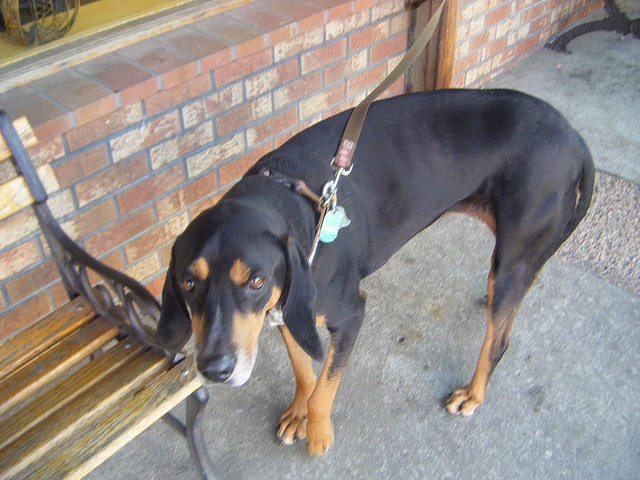Describe the objects in this image and their specific colors. I can see dog in black, gray, and darkgray tones and bench in black, gray, tan, and darkgray tones in this image. 